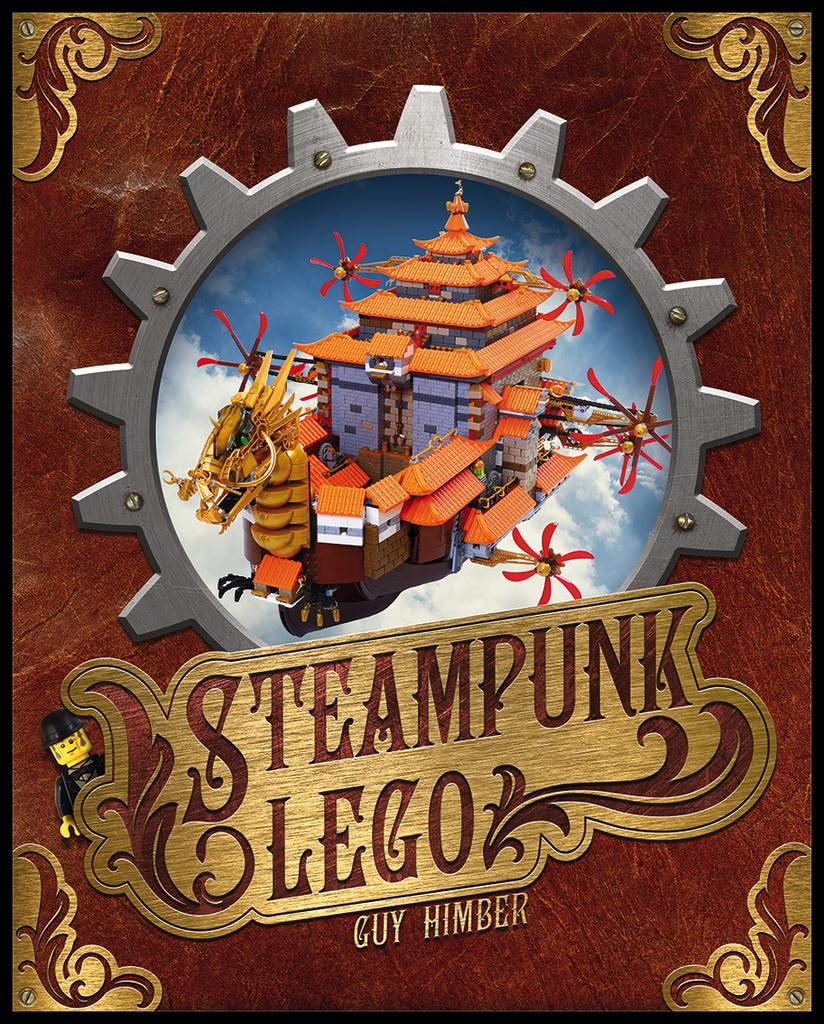<image>
Provide a brief description of the given image. A book cover of Steampunk Lego by Guy Himber. 